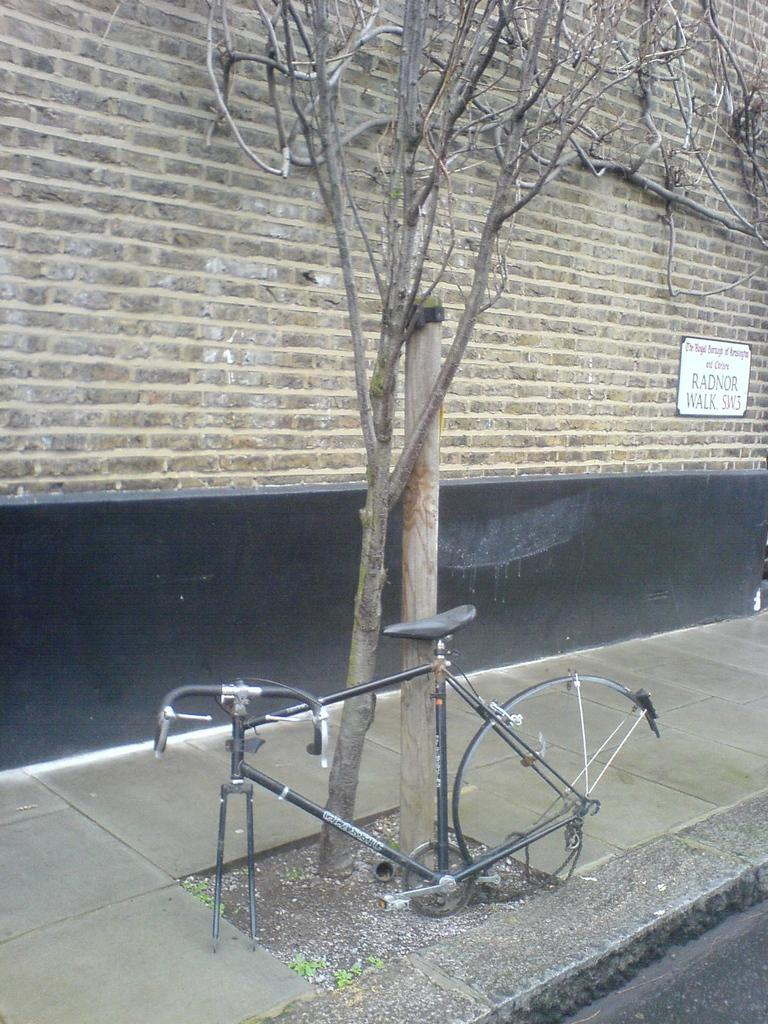What is the main object in the image? There is a bicycle in the image. What other objects or elements can be seen in the image? There is a tree, a pole, plants, walls, a board with text, and a pavement in the image. Can you describe the surroundings of the bicycle? The bicycle is near a tree, a pole, and plants, and there are walls in the background. What is written on the board in the image? The content of the text on the board cannot be determined from the image. What type of surface is the bicycle resting on? The bicycle is resting on a pavement in the image. Can you see any animals from the zoo in the image? There is no zoo or animals present in the image. What type of quilt is draped over the bicycle in the image? There is no quilt present in the image. 